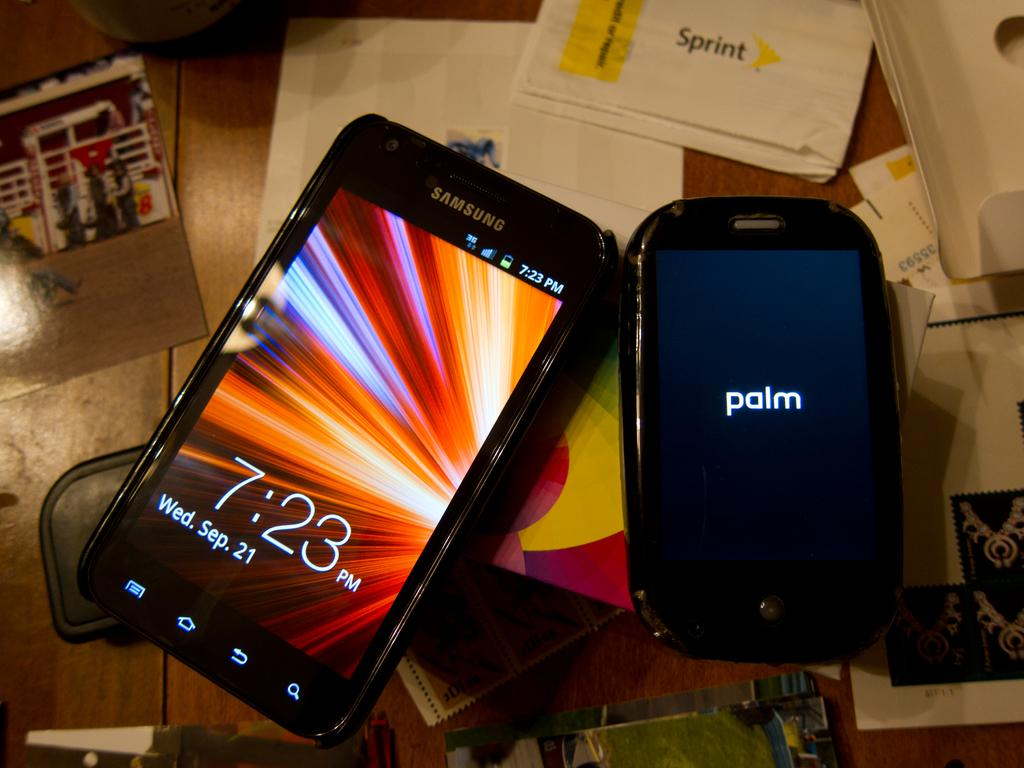Provide a one-sentence caption for the provided image. A Samsung cellphone sitting next to a smaller Palm cellphone. 